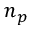Convert formula to latex. <formula><loc_0><loc_0><loc_500><loc_500>n _ { p }</formula> 